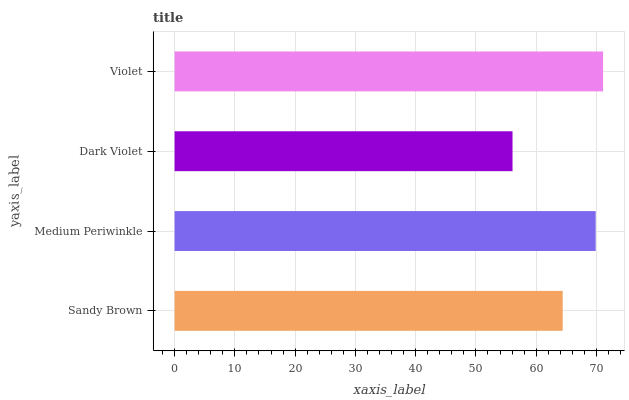Is Dark Violet the minimum?
Answer yes or no. Yes. Is Violet the maximum?
Answer yes or no. Yes. Is Medium Periwinkle the minimum?
Answer yes or no. No. Is Medium Periwinkle the maximum?
Answer yes or no. No. Is Medium Periwinkle greater than Sandy Brown?
Answer yes or no. Yes. Is Sandy Brown less than Medium Periwinkle?
Answer yes or no. Yes. Is Sandy Brown greater than Medium Periwinkle?
Answer yes or no. No. Is Medium Periwinkle less than Sandy Brown?
Answer yes or no. No. Is Medium Periwinkle the high median?
Answer yes or no. Yes. Is Sandy Brown the low median?
Answer yes or no. Yes. Is Violet the high median?
Answer yes or no. No. Is Medium Periwinkle the low median?
Answer yes or no. No. 